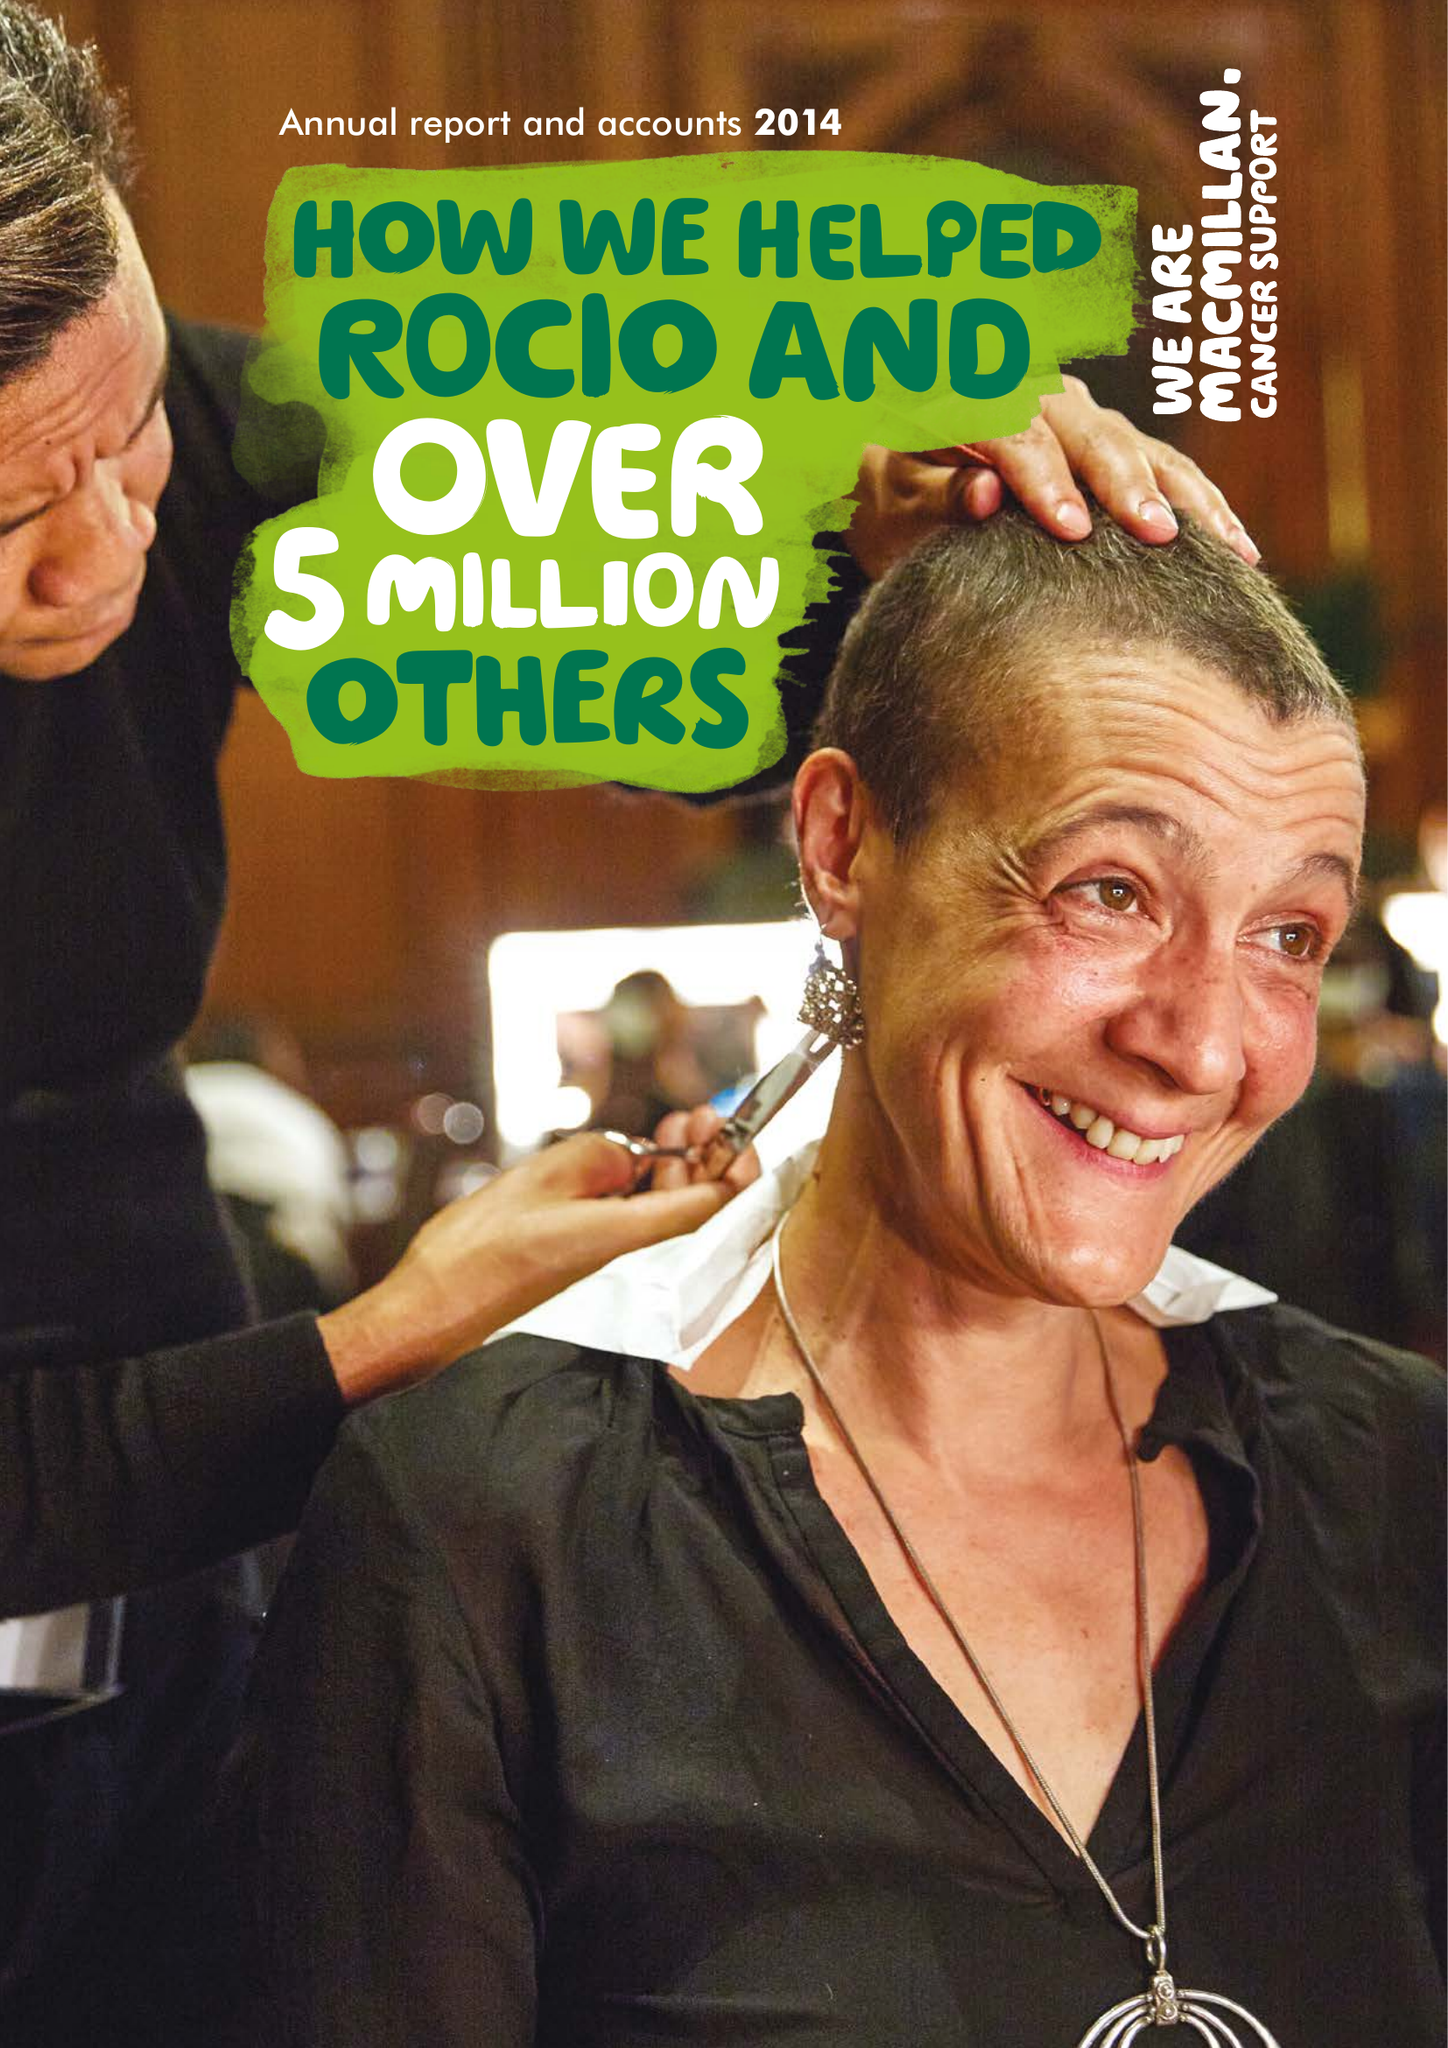What is the value for the address__post_town?
Answer the question using a single word or phrase. LONDON 